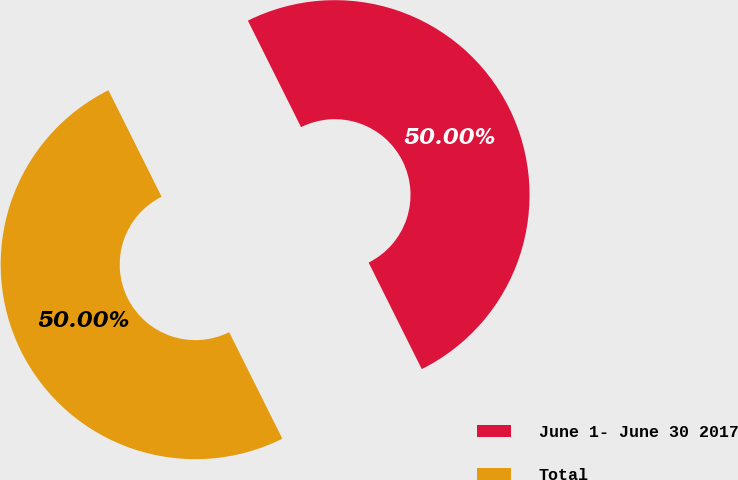<chart> <loc_0><loc_0><loc_500><loc_500><pie_chart><fcel>June 1- June 30 2017<fcel>Total<nl><fcel>50.0%<fcel>50.0%<nl></chart> 